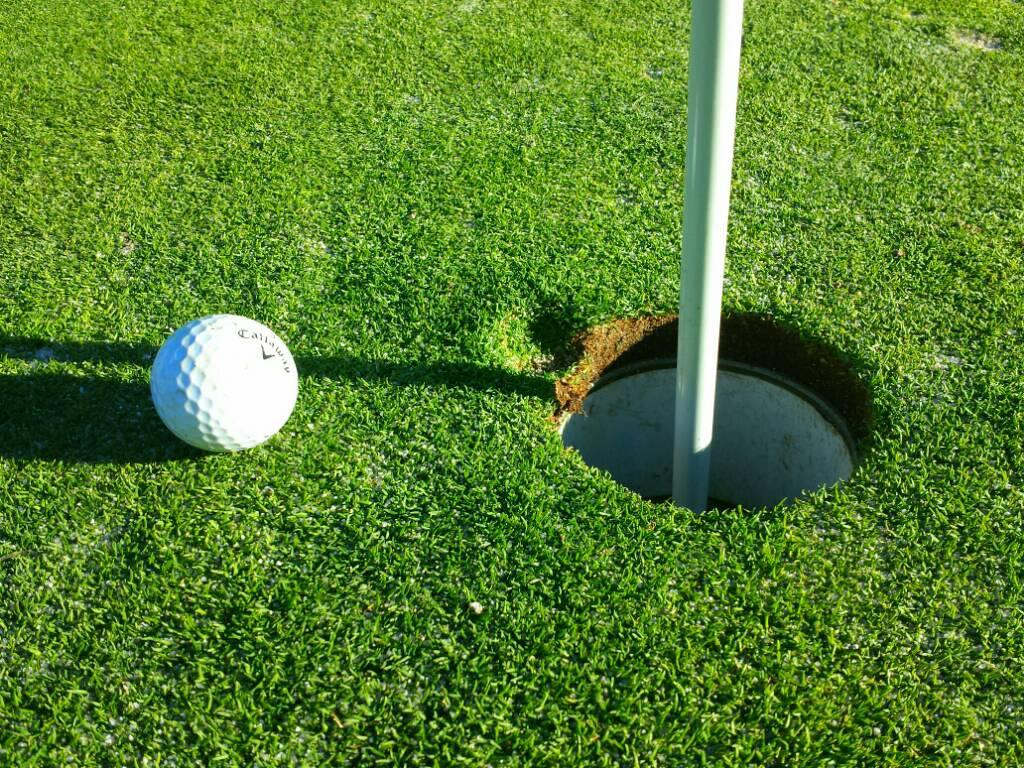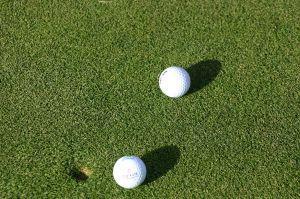The first image is the image on the left, the second image is the image on the right. Assess this claim about the two images: "At least one golf ball is within about six inches of a hole with a pole sticking out of it.". Correct or not? Answer yes or no. Yes. The first image is the image on the left, the second image is the image on the right. Considering the images on both sides, is "There are three golf balls, one on the left and two on the right, and no people." valid? Answer yes or no. Yes. 